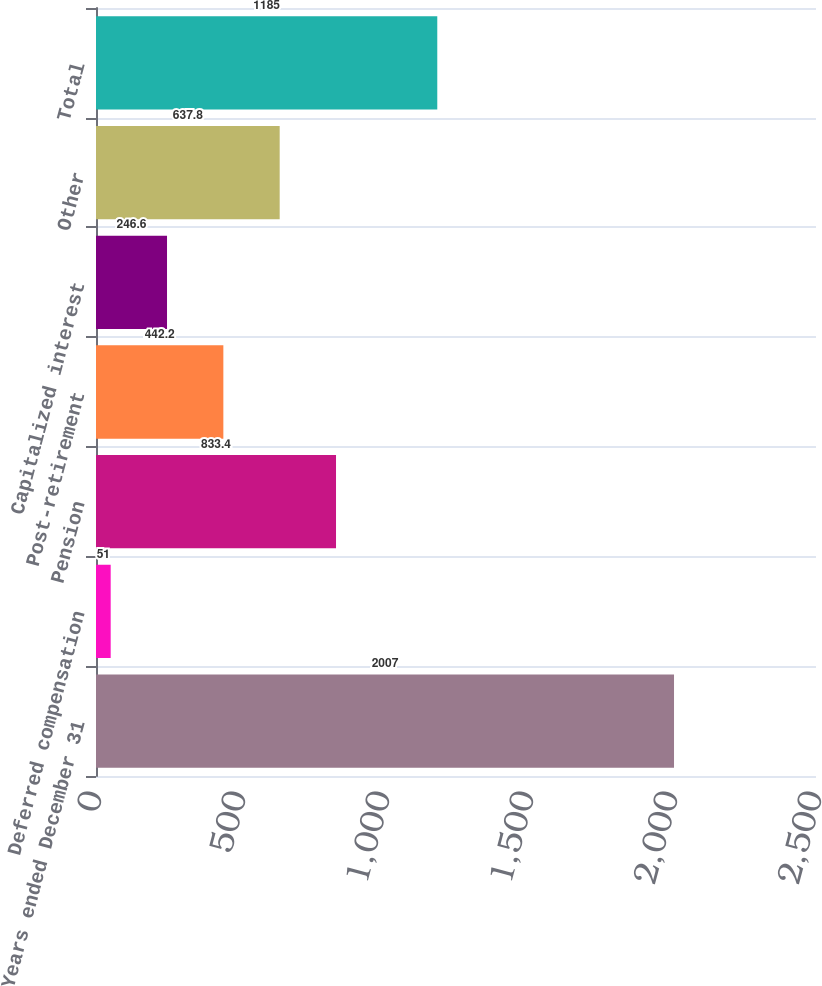Convert chart. <chart><loc_0><loc_0><loc_500><loc_500><bar_chart><fcel>Years ended December 31<fcel>Deferred compensation<fcel>Pension<fcel>Post-retirement<fcel>Capitalized interest<fcel>Other<fcel>Total<nl><fcel>2007<fcel>51<fcel>833.4<fcel>442.2<fcel>246.6<fcel>637.8<fcel>1185<nl></chart> 